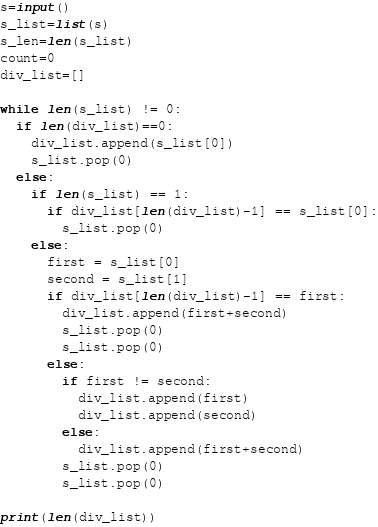<code> <loc_0><loc_0><loc_500><loc_500><_Python_>s=input()
s_list=list(s)
s_len=len(s_list)
count=0
div_list=[]

while len(s_list) != 0:
  if len(div_list)==0:
    div_list.append(s_list[0])
    s_list.pop(0)
  else:
    if len(s_list) == 1:
      if div_list[len(div_list)-1] == s_list[0]:
        s_list.pop(0)
    else:
      first = s_list[0]
      second = s_list[1]
      if div_list[len(div_list)-1] == first:
        div_list.append(first+second)
        s_list.pop(0)
        s_list.pop(0)
      else:
        if first != second:
          div_list.append(first)
          div_list.append(second)
        else:
          div_list.append(first+second)
        s_list.pop(0)
        s_list.pop(0)

print(len(div_list))</code> 